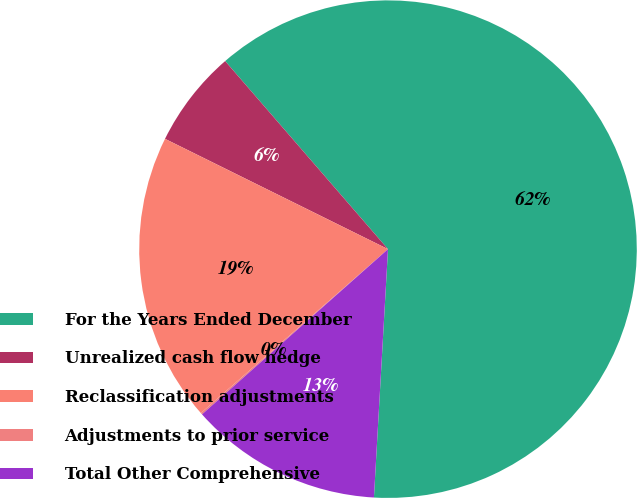<chart> <loc_0><loc_0><loc_500><loc_500><pie_chart><fcel>For the Years Ended December<fcel>Unrealized cash flow hedge<fcel>Reclassification adjustments<fcel>Adjustments to prior service<fcel>Total Other Comprehensive<nl><fcel>62.26%<fcel>6.33%<fcel>18.76%<fcel>0.11%<fcel>12.54%<nl></chart> 